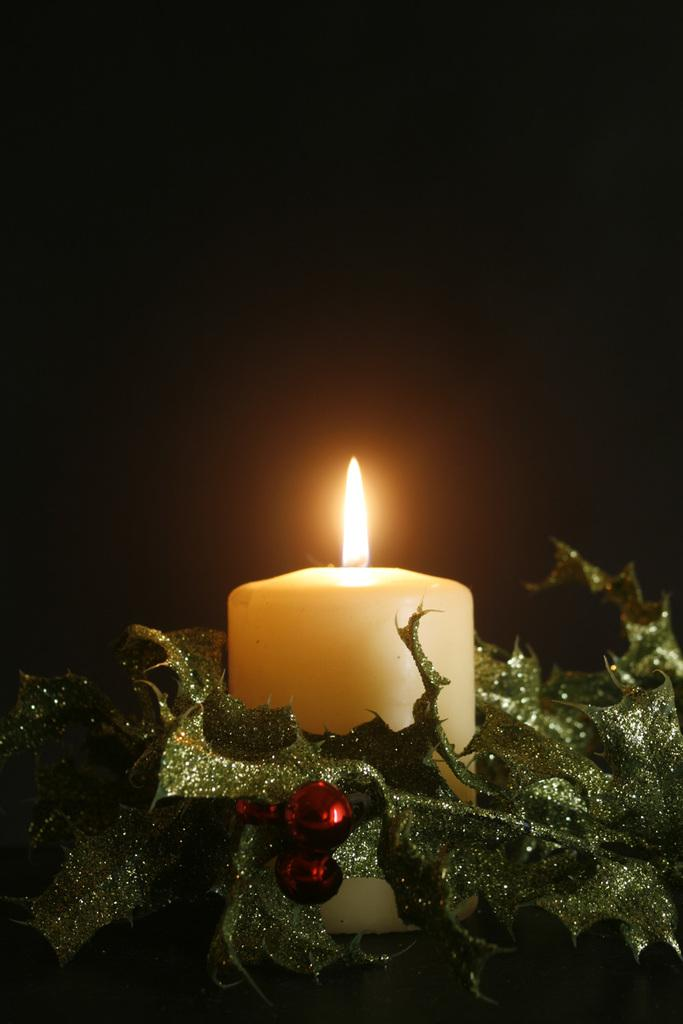What is the main source of light in the image? There is a candle with light in the image. What other objects can be seen near the candle? There are decorative items near the candle. How would you describe the overall lighting in the image? The background of the image is dark. What type of beef is being cooked on the candle in the image? There is no beef present in the image; it only features a candle with light and decorative items. 